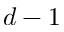<formula> <loc_0><loc_0><loc_500><loc_500>d - 1</formula> 